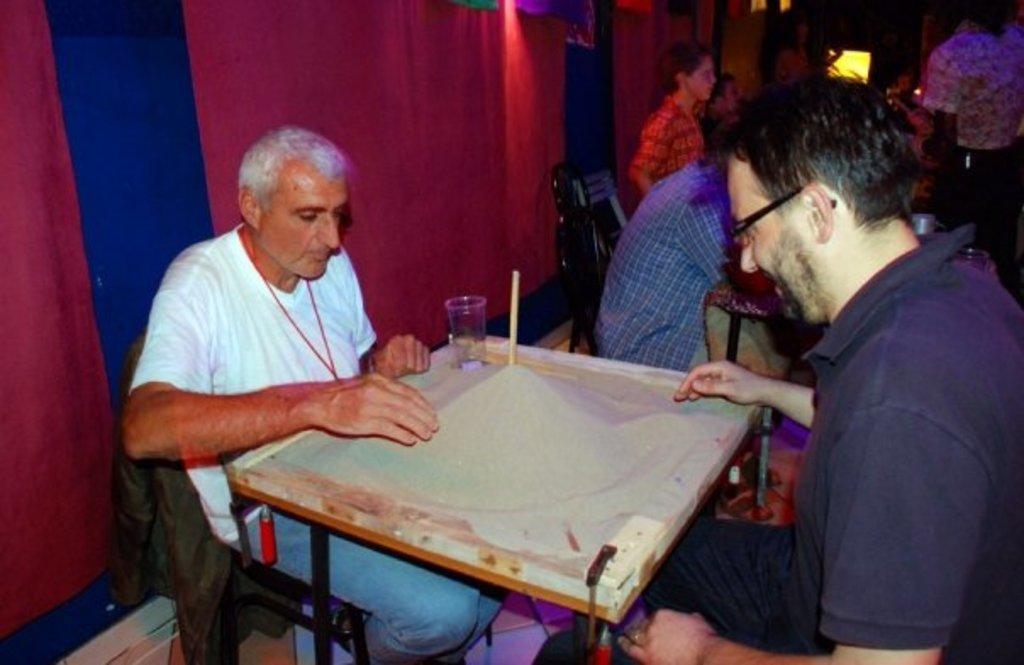Could you give a brief overview of what you see in this image? In this picture two guys are playing on the board , on top of which there is sand, stick and a glass. In the background there is a red curtain. 